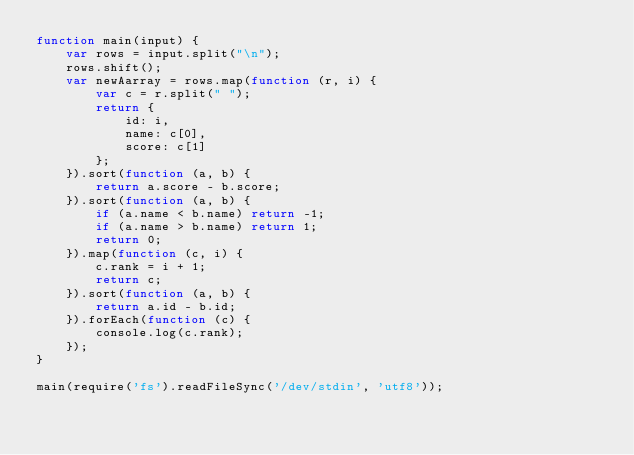<code> <loc_0><loc_0><loc_500><loc_500><_JavaScript_>function main(input) {
    var rows = input.split("\n");
    rows.shift();
    var newAarray = rows.map(function (r, i) {
        var c = r.split(" ");
        return {
            id: i,
            name: c[0],
            score: c[1]
        };
    }).sort(function (a, b) {
        return a.score - b.score;
    }).sort(function (a, b) {
        if (a.name < b.name) return -1;
        if (a.name > b.name) return 1;
        return 0;
    }).map(function (c, i) {
        c.rank = i + 1;
        return c;
    }).sort(function (a, b) {
        return a.id - b.id;
    }).forEach(function (c) {
        console.log(c.rank);
    });
}

main(require('fs').readFileSync('/dev/stdin', 'utf8'));</code> 